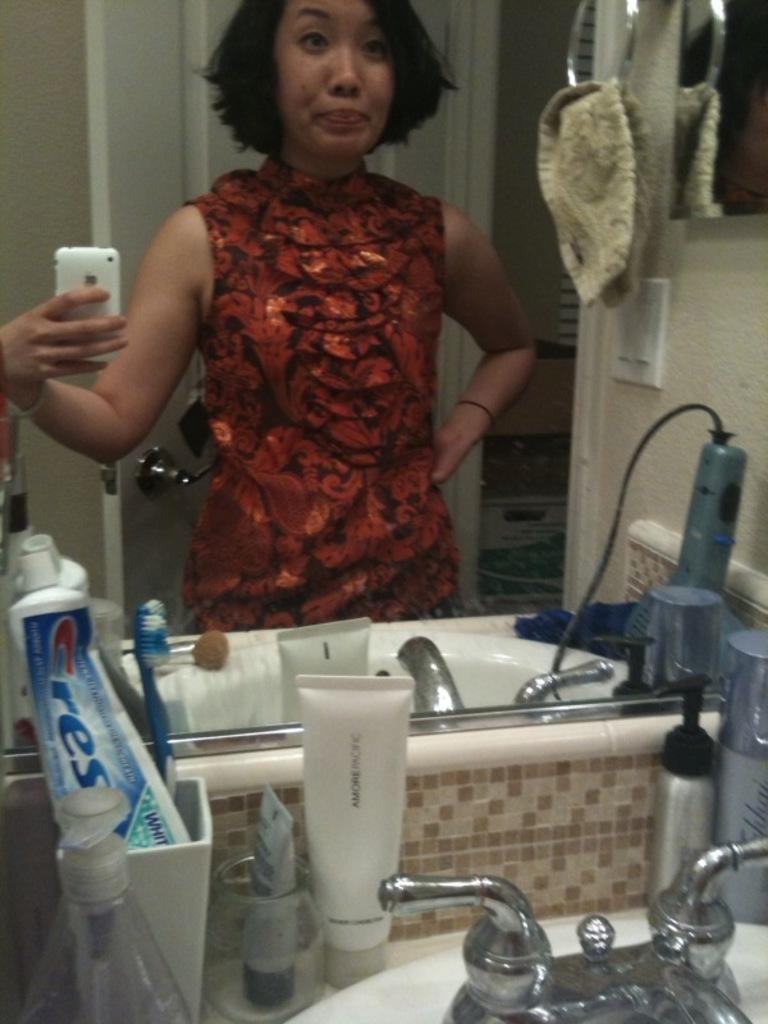<image>
Summarize the visual content of the image. Woman taking a picture in a bathroom with a Crest toothpaste. 